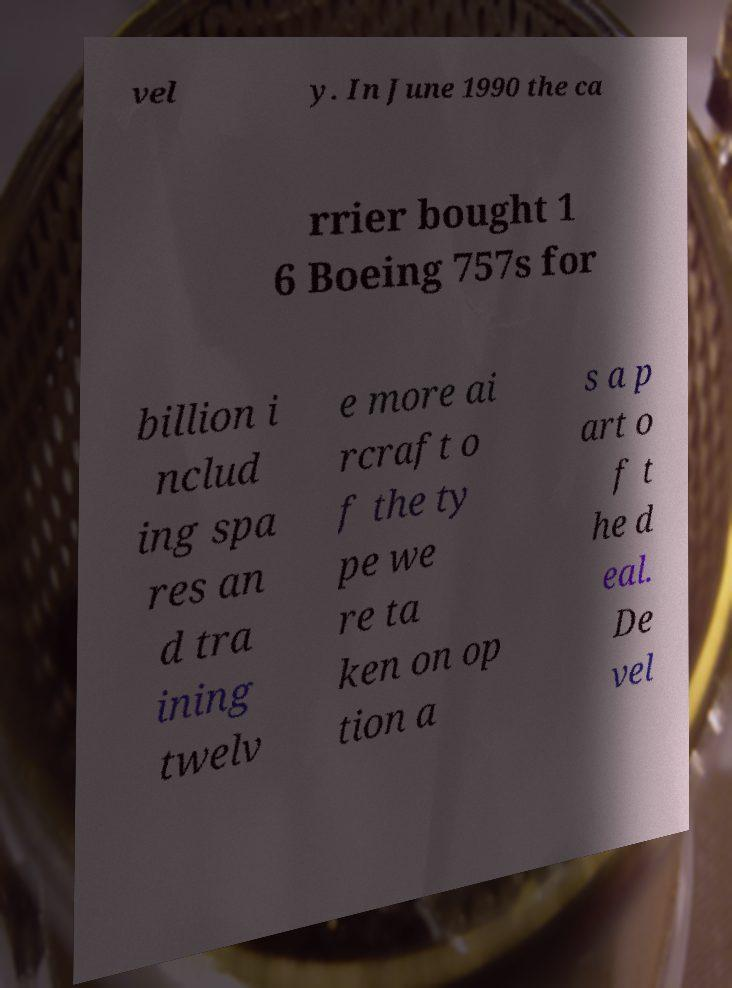I need the written content from this picture converted into text. Can you do that? vel y. In June 1990 the ca rrier bought 1 6 Boeing 757s for billion i nclud ing spa res an d tra ining twelv e more ai rcraft o f the ty pe we re ta ken on op tion a s a p art o f t he d eal. De vel 